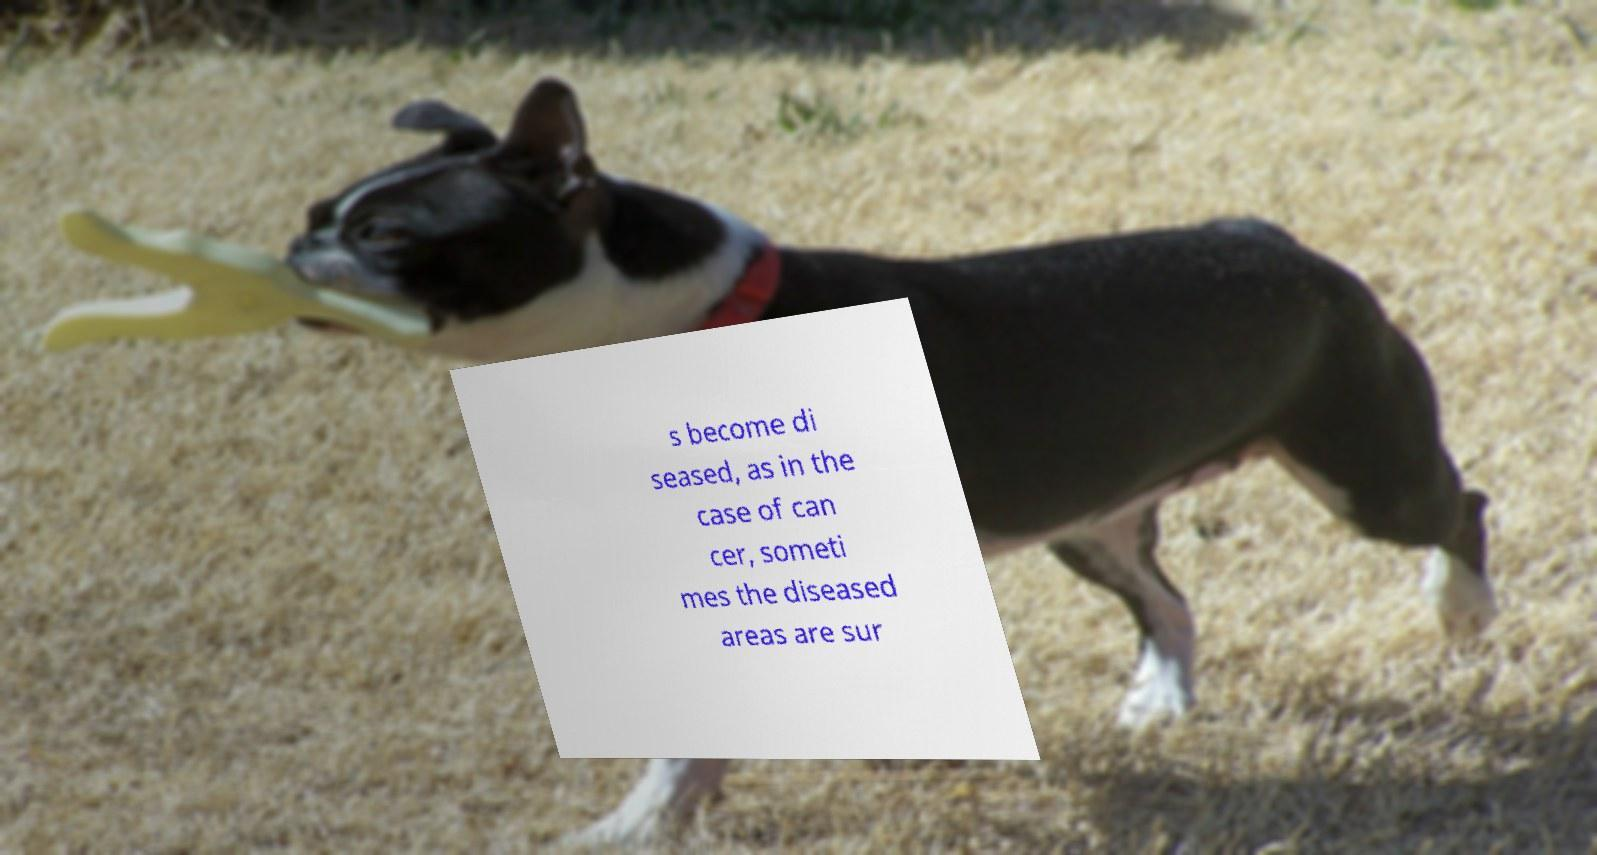What messages or text are displayed in this image? I need them in a readable, typed format. s become di seased, as in the case of can cer, someti mes the diseased areas are sur 